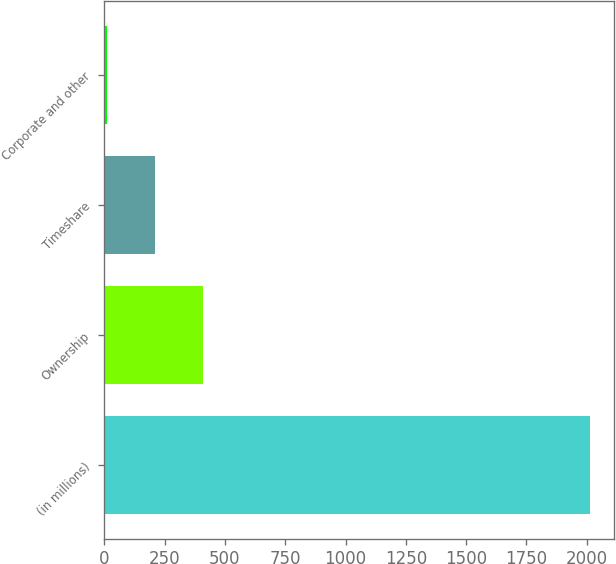Convert chart to OTSL. <chart><loc_0><loc_0><loc_500><loc_500><bar_chart><fcel>(in millions)<fcel>Ownership<fcel>Timeshare<fcel>Corporate and other<nl><fcel>2014<fcel>410<fcel>209.5<fcel>9<nl></chart> 